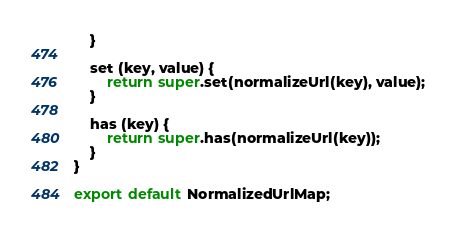<code> <loc_0><loc_0><loc_500><loc_500><_JavaScript_>	}

	set (key, value) {
		return super.set(normalizeUrl(key), value);
	}

	has (key) {
		return super.has(normalizeUrl(key));
	}
}

export default NormalizedUrlMap;
</code> 